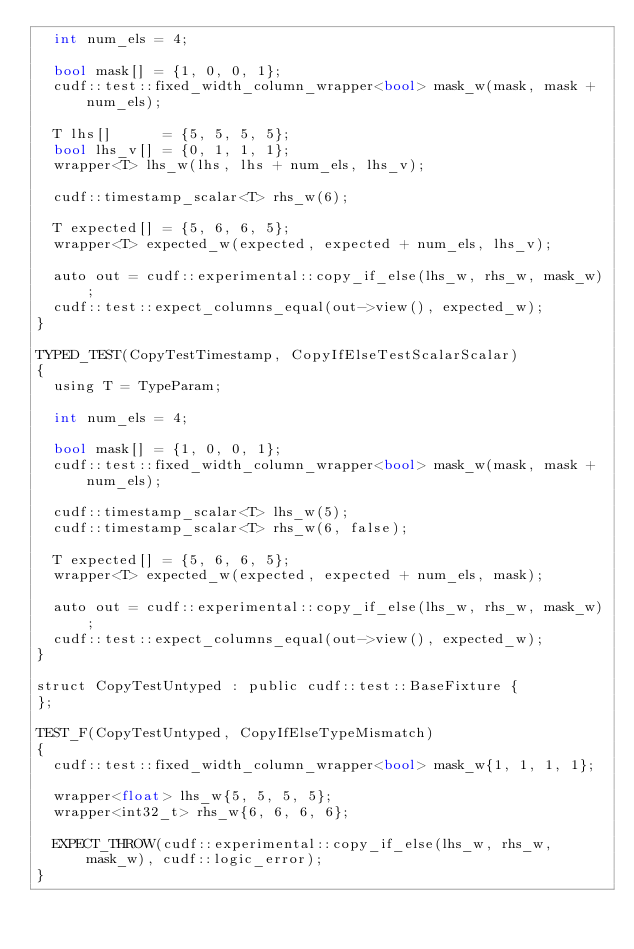<code> <loc_0><loc_0><loc_500><loc_500><_Cuda_>  int num_els = 4;

  bool mask[] = {1, 0, 0, 1};
  cudf::test::fixed_width_column_wrapper<bool> mask_w(mask, mask + num_els);

  T lhs[]      = {5, 5, 5, 5};
  bool lhs_v[] = {0, 1, 1, 1};
  wrapper<T> lhs_w(lhs, lhs + num_els, lhs_v);

  cudf::timestamp_scalar<T> rhs_w(6);

  T expected[] = {5, 6, 6, 5};
  wrapper<T> expected_w(expected, expected + num_els, lhs_v);

  auto out = cudf::experimental::copy_if_else(lhs_w, rhs_w, mask_w);
  cudf::test::expect_columns_equal(out->view(), expected_w);
}

TYPED_TEST(CopyTestTimestamp, CopyIfElseTestScalarScalar)
{
  using T = TypeParam;

  int num_els = 4;

  bool mask[] = {1, 0, 0, 1};
  cudf::test::fixed_width_column_wrapper<bool> mask_w(mask, mask + num_els);

  cudf::timestamp_scalar<T> lhs_w(5);
  cudf::timestamp_scalar<T> rhs_w(6, false);

  T expected[] = {5, 6, 6, 5};
  wrapper<T> expected_w(expected, expected + num_els, mask);

  auto out = cudf::experimental::copy_if_else(lhs_w, rhs_w, mask_w);
  cudf::test::expect_columns_equal(out->view(), expected_w);
}

struct CopyTestUntyped : public cudf::test::BaseFixture {
};

TEST_F(CopyTestUntyped, CopyIfElseTypeMismatch)
{
  cudf::test::fixed_width_column_wrapper<bool> mask_w{1, 1, 1, 1};

  wrapper<float> lhs_w{5, 5, 5, 5};
  wrapper<int32_t> rhs_w{6, 6, 6, 6};

  EXPECT_THROW(cudf::experimental::copy_if_else(lhs_w, rhs_w, mask_w), cudf::logic_error);
}
</code> 